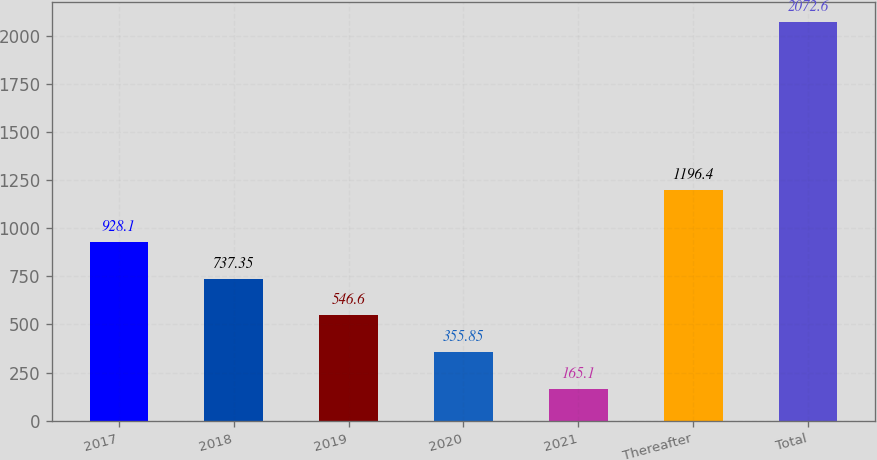Convert chart. <chart><loc_0><loc_0><loc_500><loc_500><bar_chart><fcel>2017<fcel>2018<fcel>2019<fcel>2020<fcel>2021<fcel>Thereafter<fcel>Total<nl><fcel>928.1<fcel>737.35<fcel>546.6<fcel>355.85<fcel>165.1<fcel>1196.4<fcel>2072.6<nl></chart> 